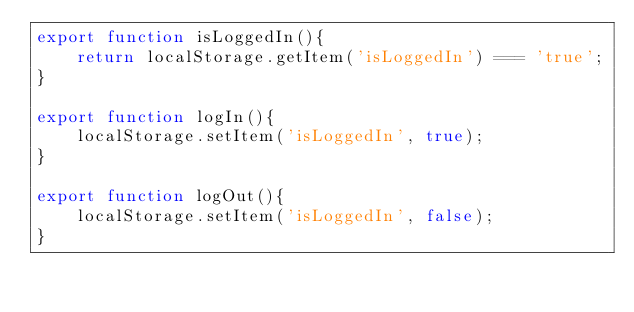<code> <loc_0><loc_0><loc_500><loc_500><_JavaScript_>export function isLoggedIn(){
    return localStorage.getItem('isLoggedIn') === 'true';
}

export function logIn(){
    localStorage.setItem('isLoggedIn', true);
}

export function logOut(){
    localStorage.setItem('isLoggedIn', false);
}
</code> 